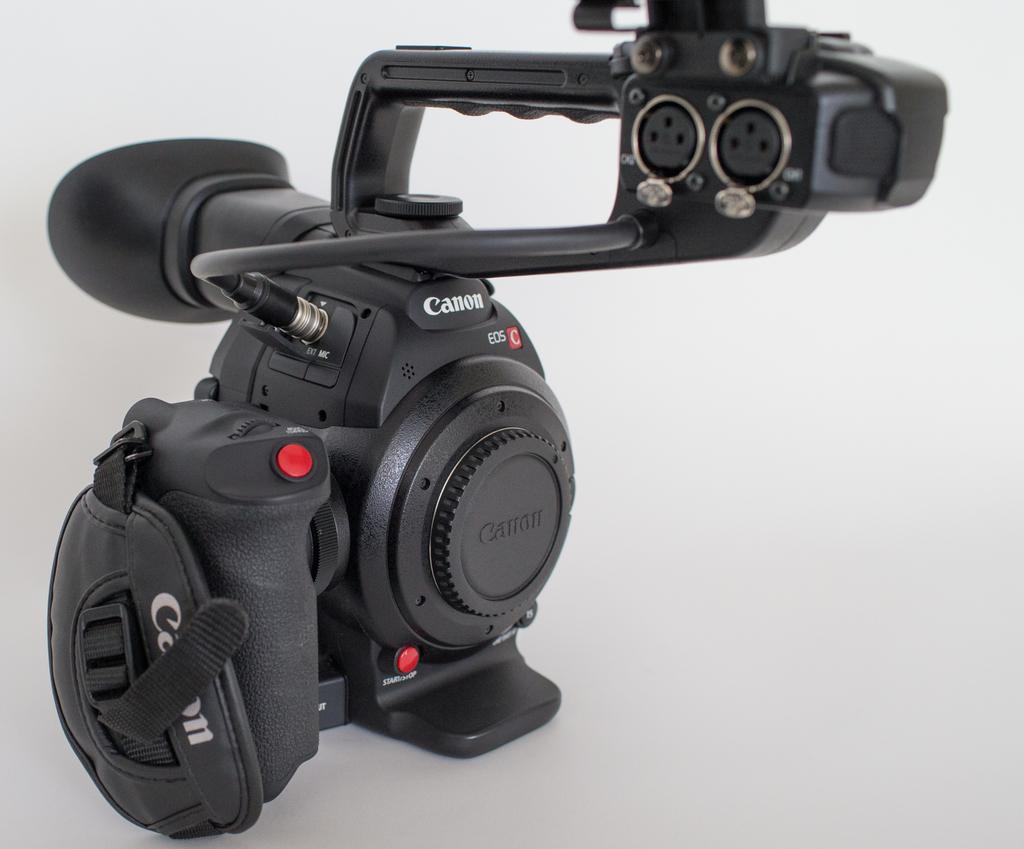Please provide a concise description of this image. In this picture we can see a device which is in black color. This is a camera. Remaining portion of the picture is in white color. 